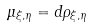Convert formula to latex. <formula><loc_0><loc_0><loc_500><loc_500>\mu _ { \xi , \eta } = d \rho _ { \xi , \eta }</formula> 